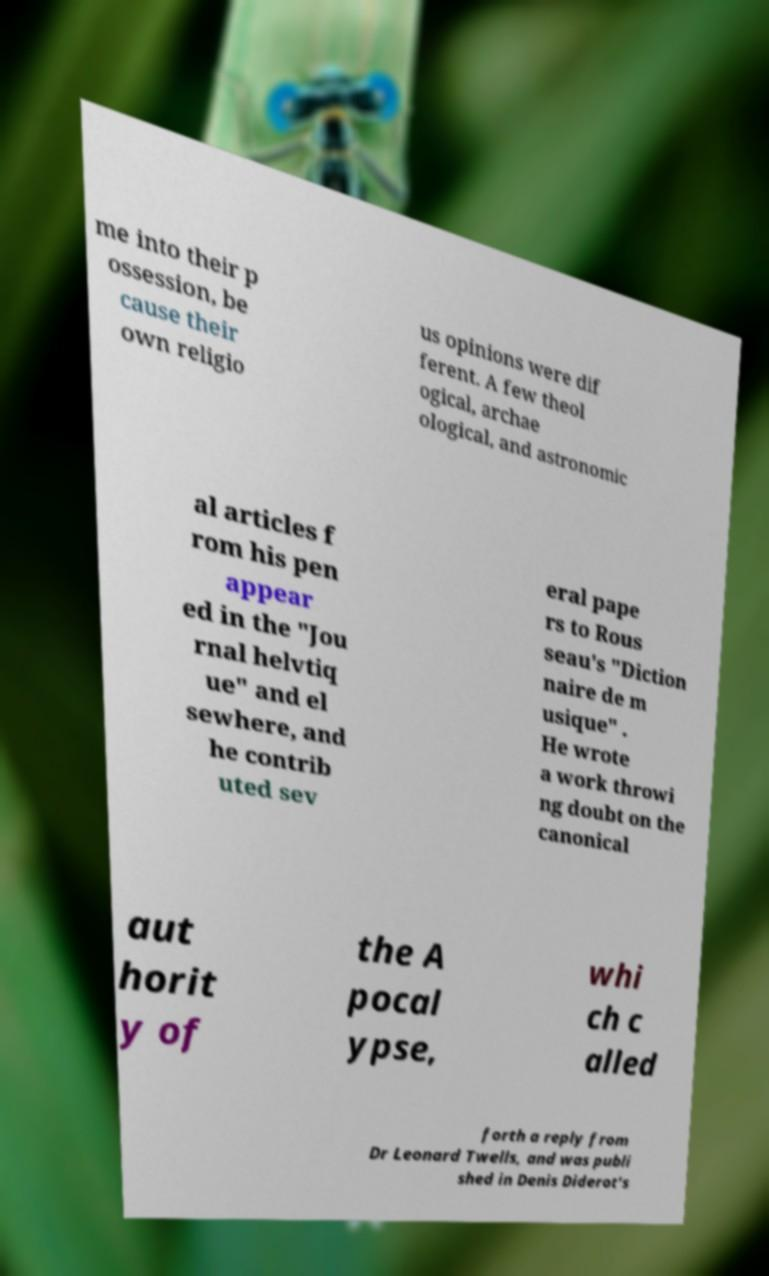Please read and relay the text visible in this image. What does it say? me into their p ossession, be cause their own religio us opinions were dif ferent. A few theol ogical, archae ological, and astronomic al articles f rom his pen appear ed in the "Jou rnal helvtiq ue" and el sewhere, and he contrib uted sev eral pape rs to Rous seau's "Diction naire de m usique" . He wrote a work throwi ng doubt on the canonical aut horit y of the A pocal ypse, whi ch c alled forth a reply from Dr Leonard Twells, and was publi shed in Denis Diderot's 